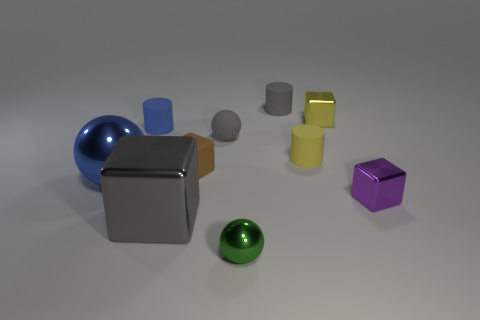The matte ball that is the same color as the big shiny block is what size?
Provide a succinct answer. Small. Do the brown thing behind the big block and the yellow rubber thing have the same shape?
Give a very brief answer. No. How many shiny balls are the same size as the yellow metal thing?
Offer a very short reply. 1. The thing that is the same color as the big ball is what shape?
Your answer should be very brief. Cylinder. There is a metallic object that is behind the big blue sphere; are there any yellow cylinders behind it?
Your answer should be very brief. No. How many objects are either tiny things that are behind the blue rubber thing or metallic blocks?
Make the answer very short. 4. What number of yellow blocks are there?
Provide a succinct answer. 1. What is the shape of the yellow object that is made of the same material as the brown object?
Offer a very short reply. Cylinder. There is a metallic ball to the left of the tiny gray rubber object in front of the blue cylinder; how big is it?
Your response must be concise. Large. What number of things are small gray rubber things that are on the right side of the tiny green metallic ball or tiny objects on the left side of the small purple object?
Your response must be concise. 7. 